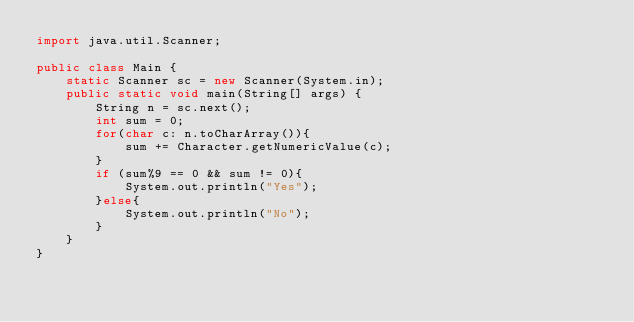Convert code to text. <code><loc_0><loc_0><loc_500><loc_500><_Java_>import java.util.Scanner;

public class Main {
    static Scanner sc = new Scanner(System.in);
    public static void main(String[] args) {
        String n = sc.next();
        int sum = 0;
        for(char c: n.toCharArray()){
            sum += Character.getNumericValue(c);
        }
        if (sum%9 == 0 && sum != 0){
            System.out.println("Yes");
        }else{
            System.out.println("No");
        }
    }    
}</code> 